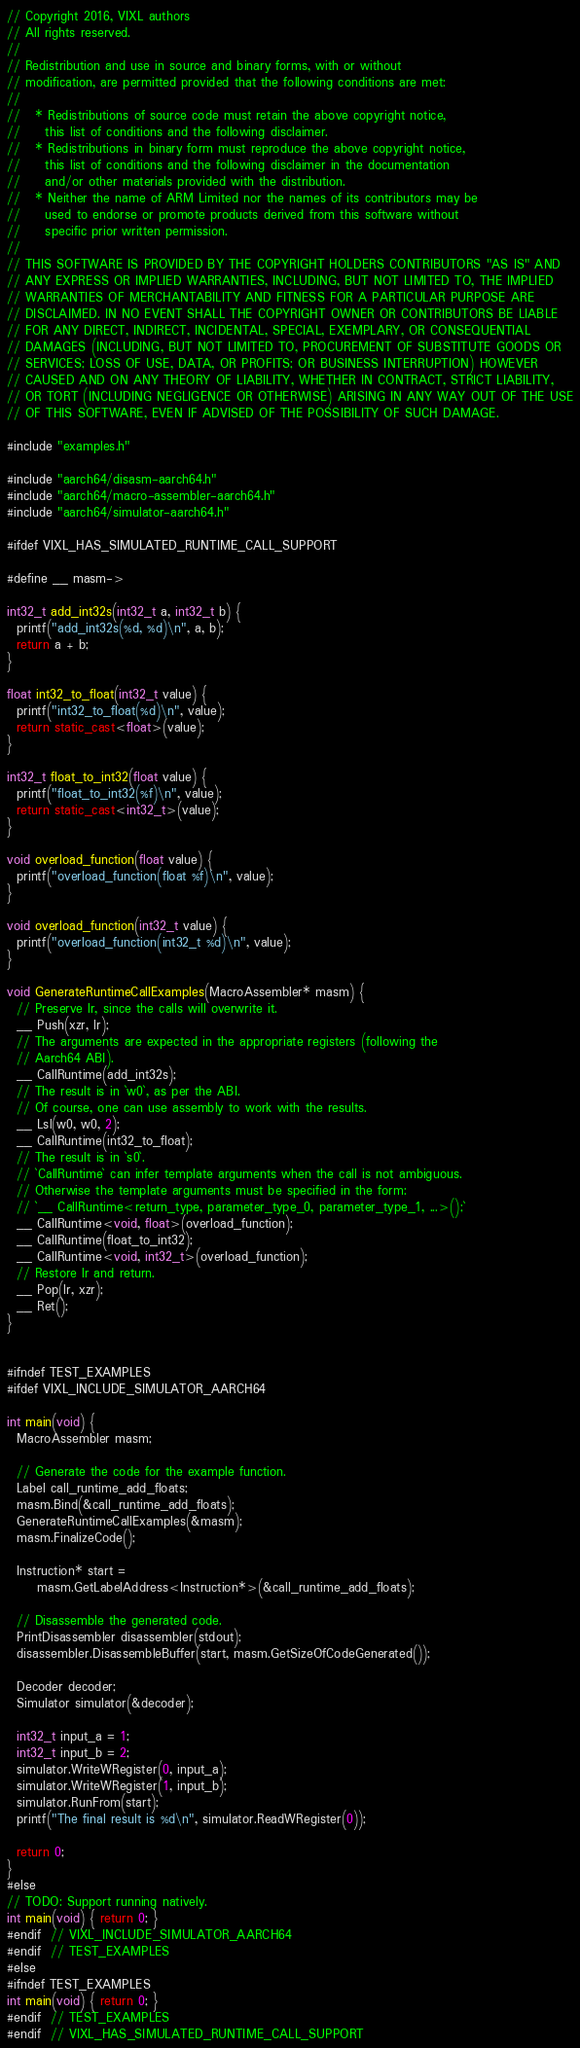<code> <loc_0><loc_0><loc_500><loc_500><_C++_>// Copyright 2016, VIXL authors
// All rights reserved.
//
// Redistribution and use in source and binary forms, with or without
// modification, are permitted provided that the following conditions are met:
//
//   * Redistributions of source code must retain the above copyright notice,
//     this list of conditions and the following disclaimer.
//   * Redistributions in binary form must reproduce the above copyright notice,
//     this list of conditions and the following disclaimer in the documentation
//     and/or other materials provided with the distribution.
//   * Neither the name of ARM Limited nor the names of its contributors may be
//     used to endorse or promote products derived from this software without
//     specific prior written permission.
//
// THIS SOFTWARE IS PROVIDED BY THE COPYRIGHT HOLDERS CONTRIBUTORS "AS IS" AND
// ANY EXPRESS OR IMPLIED WARRANTIES, INCLUDING, BUT NOT LIMITED TO, THE IMPLIED
// WARRANTIES OF MERCHANTABILITY AND FITNESS FOR A PARTICULAR PURPOSE ARE
// DISCLAIMED. IN NO EVENT SHALL THE COPYRIGHT OWNER OR CONTRIBUTORS BE LIABLE
// FOR ANY DIRECT, INDIRECT, INCIDENTAL, SPECIAL, EXEMPLARY, OR CONSEQUENTIAL
// DAMAGES (INCLUDING, BUT NOT LIMITED TO, PROCUREMENT OF SUBSTITUTE GOODS OR
// SERVICES; LOSS OF USE, DATA, OR PROFITS; OR BUSINESS INTERRUPTION) HOWEVER
// CAUSED AND ON ANY THEORY OF LIABILITY, WHETHER IN CONTRACT, STRICT LIABILITY,
// OR TORT (INCLUDING NEGLIGENCE OR OTHERWISE) ARISING IN ANY WAY OUT OF THE USE
// OF THIS SOFTWARE, EVEN IF ADVISED OF THE POSSIBILITY OF SUCH DAMAGE.

#include "examples.h"

#include "aarch64/disasm-aarch64.h"
#include "aarch64/macro-assembler-aarch64.h"
#include "aarch64/simulator-aarch64.h"

#ifdef VIXL_HAS_SIMULATED_RUNTIME_CALL_SUPPORT

#define __ masm->

int32_t add_int32s(int32_t a, int32_t b) {
  printf("add_int32s(%d, %d)\n", a, b);
  return a + b;
}

float int32_to_float(int32_t value) {
  printf("int32_to_float(%d)\n", value);
  return static_cast<float>(value);
}

int32_t float_to_int32(float value) {
  printf("float_to_int32(%f)\n", value);
  return static_cast<int32_t>(value);
}

void overload_function(float value) {
  printf("overload_function(float %f)\n", value);
}

void overload_function(int32_t value) {
  printf("overload_function(int32_t %d)\n", value);
}

void GenerateRuntimeCallExamples(MacroAssembler* masm) {
  // Preserve lr, since the calls will overwrite it.
  __ Push(xzr, lr);
  // The arguments are expected in the appropriate registers (following the
  // Aarch64 ABI).
  __ CallRuntime(add_int32s);
  // The result is in `w0`, as per the ABI.
  // Of course, one can use assembly to work with the results.
  __ Lsl(w0, w0, 2);
  __ CallRuntime(int32_to_float);
  // The result is in `s0`.
  // `CallRuntime` can infer template arguments when the call is not ambiguous.
  // Otherwise the template arguments must be specified in the form:
  // `__ CallRuntime<return_type, parameter_type_0, parameter_type_1, ...>();`
  __ CallRuntime<void, float>(overload_function);
  __ CallRuntime(float_to_int32);
  __ CallRuntime<void, int32_t>(overload_function);
  // Restore lr and return.
  __ Pop(lr, xzr);
  __ Ret();
}


#ifndef TEST_EXAMPLES
#ifdef VIXL_INCLUDE_SIMULATOR_AARCH64

int main(void) {
  MacroAssembler masm;

  // Generate the code for the example function.
  Label call_runtime_add_floats;
  masm.Bind(&call_runtime_add_floats);
  GenerateRuntimeCallExamples(&masm);
  masm.FinalizeCode();

  Instruction* start =
      masm.GetLabelAddress<Instruction*>(&call_runtime_add_floats);

  // Disassemble the generated code.
  PrintDisassembler disassembler(stdout);
  disassembler.DisassembleBuffer(start, masm.GetSizeOfCodeGenerated());

  Decoder decoder;
  Simulator simulator(&decoder);

  int32_t input_a = 1;
  int32_t input_b = 2;
  simulator.WriteWRegister(0, input_a);
  simulator.WriteWRegister(1, input_b);
  simulator.RunFrom(start);
  printf("The final result is %d\n", simulator.ReadWRegister(0));

  return 0;
}
#else
// TODO: Support running natively.
int main(void) { return 0; }
#endif  // VIXL_INCLUDE_SIMULATOR_AARCH64
#endif  // TEST_EXAMPLES
#else
#ifndef TEST_EXAMPLES
int main(void) { return 0; }
#endif  // TEST_EXAMPLES
#endif  // VIXL_HAS_SIMULATED_RUNTIME_CALL_SUPPORT
</code> 